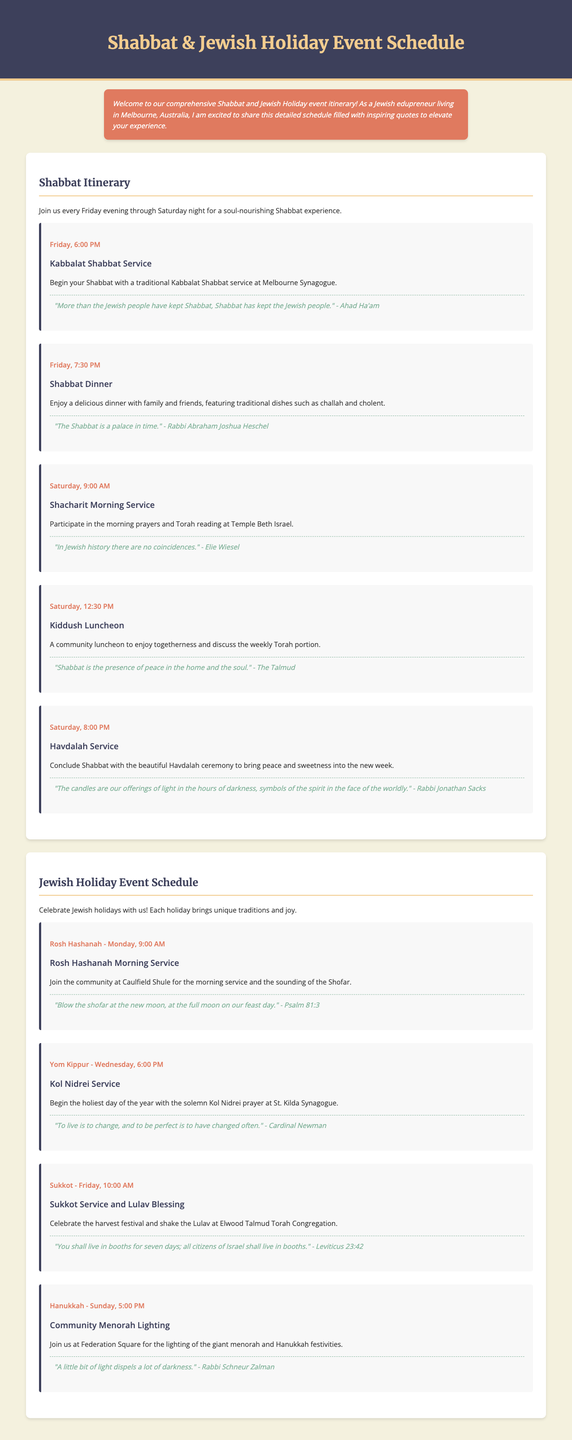what time does Kabbalat Shabbat service start? The document states that the Kabbalat Shabbat service begins at 6:00 PM on Friday.
Answer: 6:00 PM what is the theme of the quote associated with Shabbat Dinner? The quote connected to Shabbat Dinner emphasizes the idea of Shabbat being a peaceful palace in time.
Answer: "The Shabbat is a palace in time." - Rabbi Abraham Joshua Heschel which holiday includes the sounding of the Shofar? According to the document, the Rosh Hashanah morning service includes the sounding of the Shofar.
Answer: Rosh Hashanah what event is scheduled for Saturday at 12:30 PM? The document lists the Kiddush Luncheon as the event at this time on Saturday.
Answer: Kiddush Luncheon who delivers the quote about light dispelling darkness? The quote about light comes from Rabbi Schneur Zalman, as noted in the document.
Answer: Rabbi Schneur Zalman how many events are listed under the Jewish Holiday Event Schedule? The document lists a total of four events under the Jewish Holiday Event Schedule.
Answer: Four what location is mentioned for the Havdalah Service? The document indicates that the Havdalah Service occurs after Shabbat at the specified location.
Answer: Not specified what is the first event in the Shabbat itinerary? The Kabbalat Shabbat Service is the first event listed in the Shabbat itinerary.
Answer: Kabbalat Shabbat Service which holiday's service is held at 6:00 PM on a Wednesday? The Kol Nidrei Service for Yom Kippur is scheduled for 6:00 PM on Wednesday.
Answer: Yom Kippur 